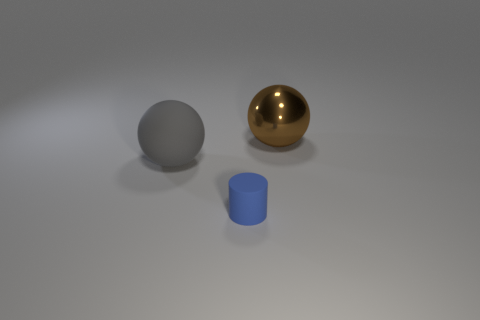What is the size of the blue rubber object?
Your response must be concise. Small. Is the number of brown shiny spheres in front of the large matte thing less than the number of red metal balls?
Your response must be concise. No. What number of other gray matte objects are the same size as the gray matte thing?
Provide a succinct answer. 0. Is the color of the big sphere that is left of the cylinder the same as the object right of the tiny blue matte object?
Offer a terse response. No. There is a shiny ball; what number of metal spheres are to the right of it?
Your response must be concise. 0. Is there another big matte thing of the same shape as the gray object?
Provide a succinct answer. No. What is the color of the metal ball that is the same size as the matte ball?
Ensure brevity in your answer.  Brown. Are there fewer big matte things to the right of the small rubber cylinder than brown spheres behind the big metal ball?
Your answer should be very brief. No. There is a thing that is behind the gray object; is it the same size as the tiny blue cylinder?
Provide a short and direct response. No. There is a object in front of the big gray sphere; what shape is it?
Ensure brevity in your answer.  Cylinder. 